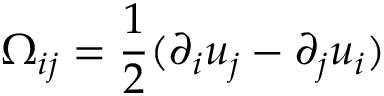<formula> <loc_0><loc_0><loc_500><loc_500>\Omega _ { i j } = \frac { 1 } { 2 } ( \partial _ { i } u _ { j } - \partial _ { j } u _ { i } )</formula> 